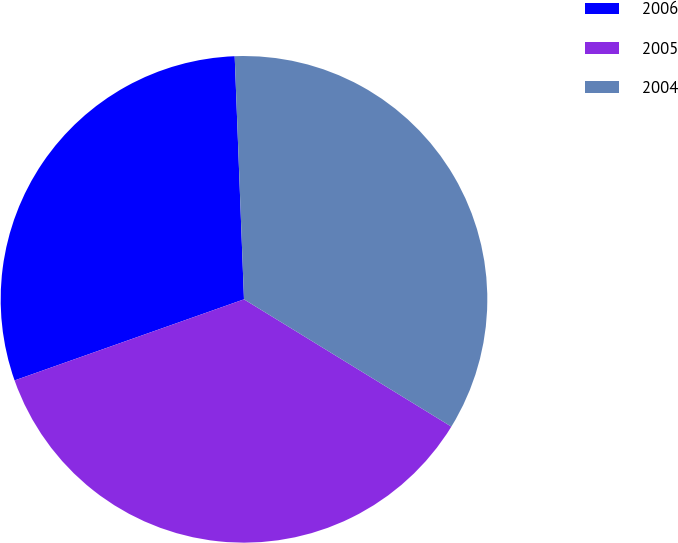<chart> <loc_0><loc_0><loc_500><loc_500><pie_chart><fcel>2006<fcel>2005<fcel>2004<nl><fcel>29.8%<fcel>35.83%<fcel>34.37%<nl></chart> 